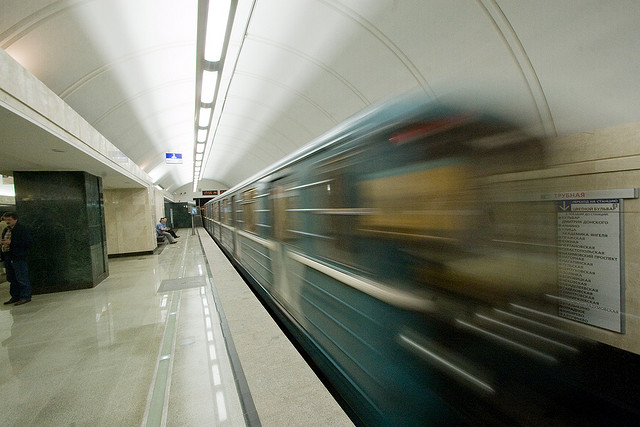What mood does the motion blur of the train evoke in the image? The motion blur of the train evokes a sense of rapid movement and the bustling rhythm of city life. It captures the essence of urban transportation where everything is dynamic and time-sensitive. 